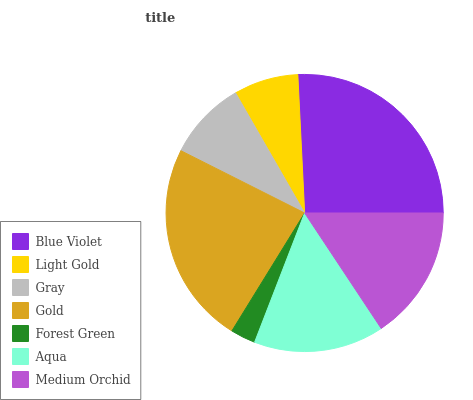Is Forest Green the minimum?
Answer yes or no. Yes. Is Blue Violet the maximum?
Answer yes or no. Yes. Is Light Gold the minimum?
Answer yes or no. No. Is Light Gold the maximum?
Answer yes or no. No. Is Blue Violet greater than Light Gold?
Answer yes or no. Yes. Is Light Gold less than Blue Violet?
Answer yes or no. Yes. Is Light Gold greater than Blue Violet?
Answer yes or no. No. Is Blue Violet less than Light Gold?
Answer yes or no. No. Is Aqua the high median?
Answer yes or no. Yes. Is Aqua the low median?
Answer yes or no. Yes. Is Gold the high median?
Answer yes or no. No. Is Medium Orchid the low median?
Answer yes or no. No. 